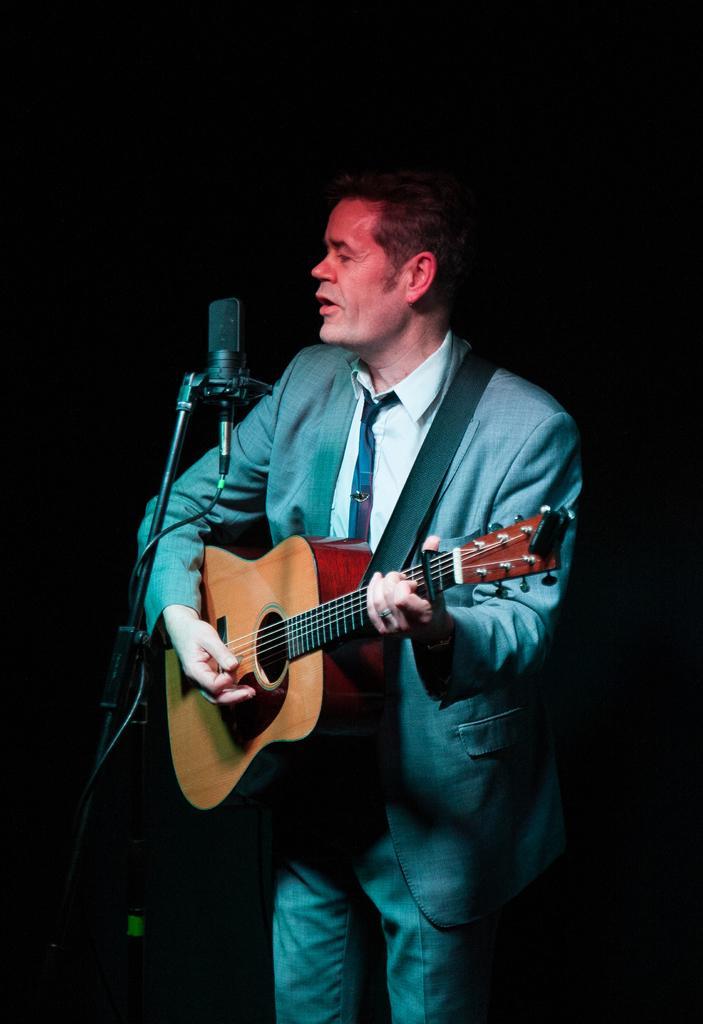Describe this image in one or two sentences. In this picture we can see a man who is standing in front of mike and he is playing guitar. 